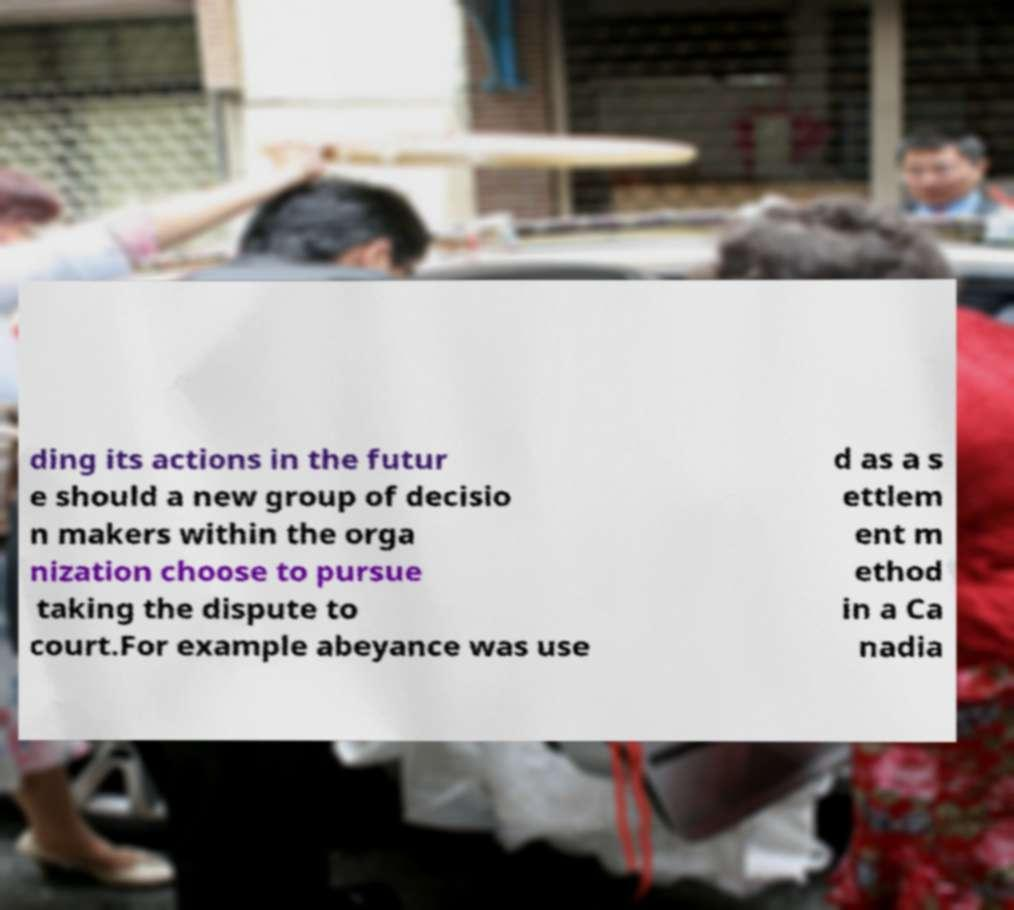There's text embedded in this image that I need extracted. Can you transcribe it verbatim? ding its actions in the futur e should a new group of decisio n makers within the orga nization choose to pursue taking the dispute to court.For example abeyance was use d as a s ettlem ent m ethod in a Ca nadia 